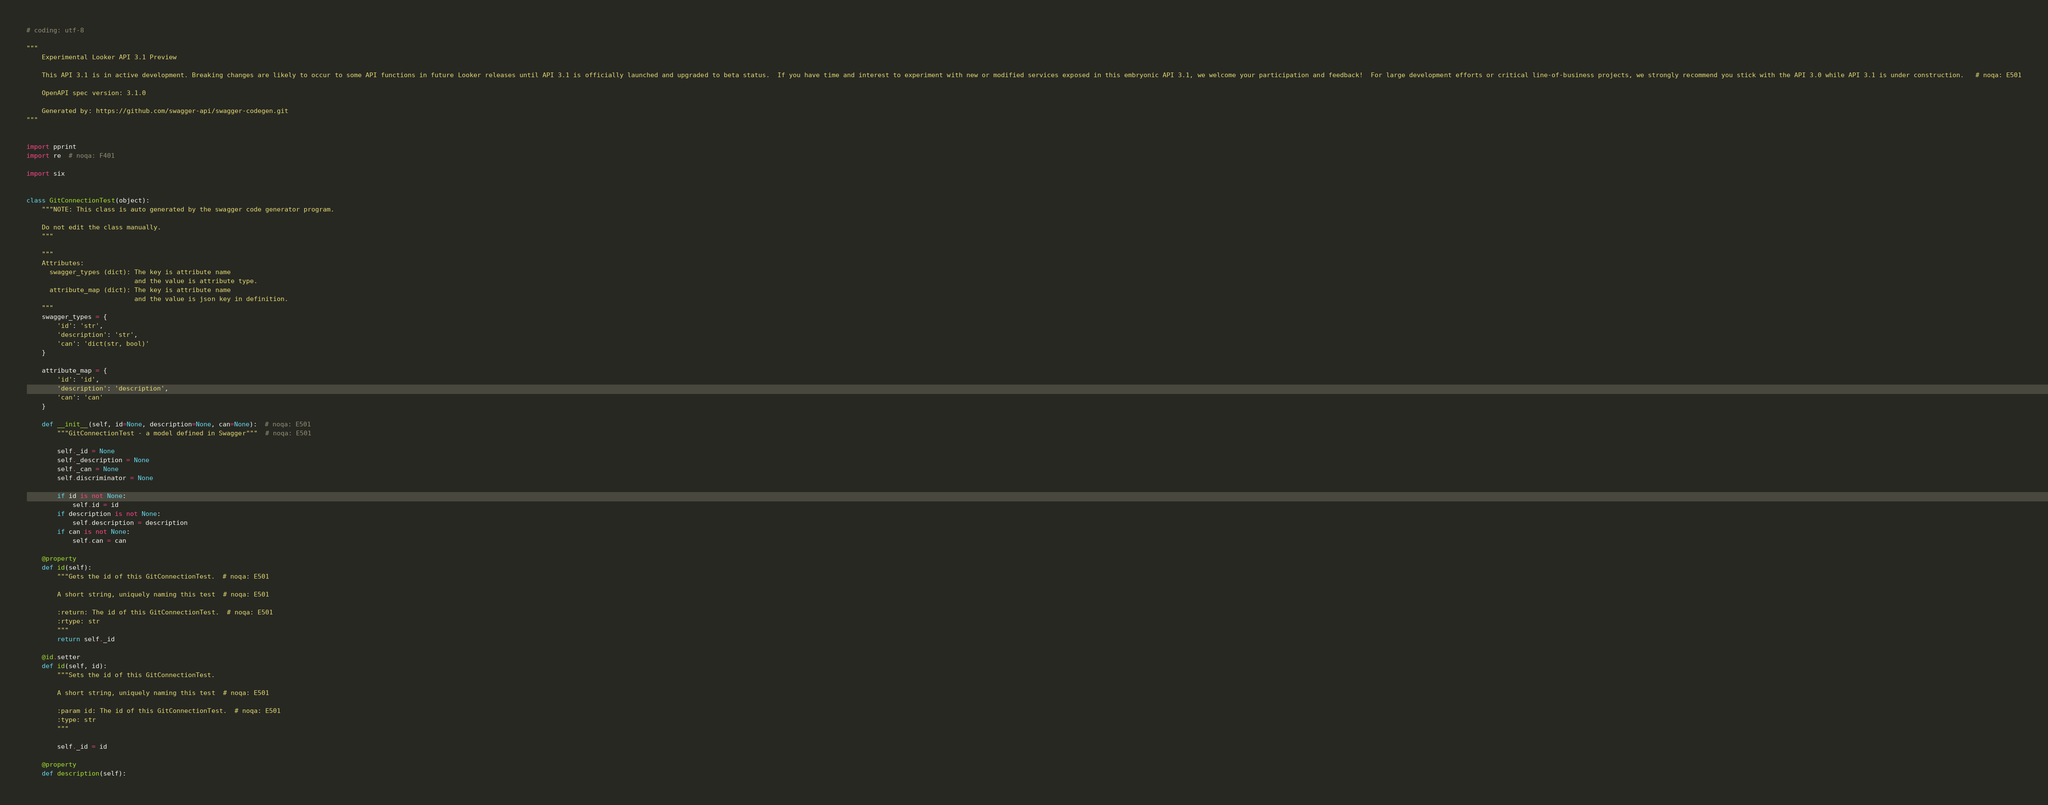Convert code to text. <code><loc_0><loc_0><loc_500><loc_500><_Python_># coding: utf-8

"""
    Experimental Looker API 3.1 Preview

    This API 3.1 is in active development. Breaking changes are likely to occur to some API functions in future Looker releases until API 3.1 is officially launched and upgraded to beta status.  If you have time and interest to experiment with new or modified services exposed in this embryonic API 3.1, we welcome your participation and feedback!  For large development efforts or critical line-of-business projects, we strongly recommend you stick with the API 3.0 while API 3.1 is under construction.   # noqa: E501

    OpenAPI spec version: 3.1.0
    
    Generated by: https://github.com/swagger-api/swagger-codegen.git
"""


import pprint
import re  # noqa: F401

import six


class GitConnectionTest(object):
    """NOTE: This class is auto generated by the swagger code generator program.

    Do not edit the class manually.
    """

    """
    Attributes:
      swagger_types (dict): The key is attribute name
                            and the value is attribute type.
      attribute_map (dict): The key is attribute name
                            and the value is json key in definition.
    """
    swagger_types = {
        'id': 'str',
        'description': 'str',
        'can': 'dict(str, bool)'
    }

    attribute_map = {
        'id': 'id',
        'description': 'description',
        'can': 'can'
    }

    def __init__(self, id=None, description=None, can=None):  # noqa: E501
        """GitConnectionTest - a model defined in Swagger"""  # noqa: E501

        self._id = None
        self._description = None
        self._can = None
        self.discriminator = None

        if id is not None:
            self.id = id
        if description is not None:
            self.description = description
        if can is not None:
            self.can = can

    @property
    def id(self):
        """Gets the id of this GitConnectionTest.  # noqa: E501

        A short string, uniquely naming this test  # noqa: E501

        :return: The id of this GitConnectionTest.  # noqa: E501
        :rtype: str
        """
        return self._id

    @id.setter
    def id(self, id):
        """Sets the id of this GitConnectionTest.

        A short string, uniquely naming this test  # noqa: E501

        :param id: The id of this GitConnectionTest.  # noqa: E501
        :type: str
        """

        self._id = id

    @property
    def description(self):</code> 